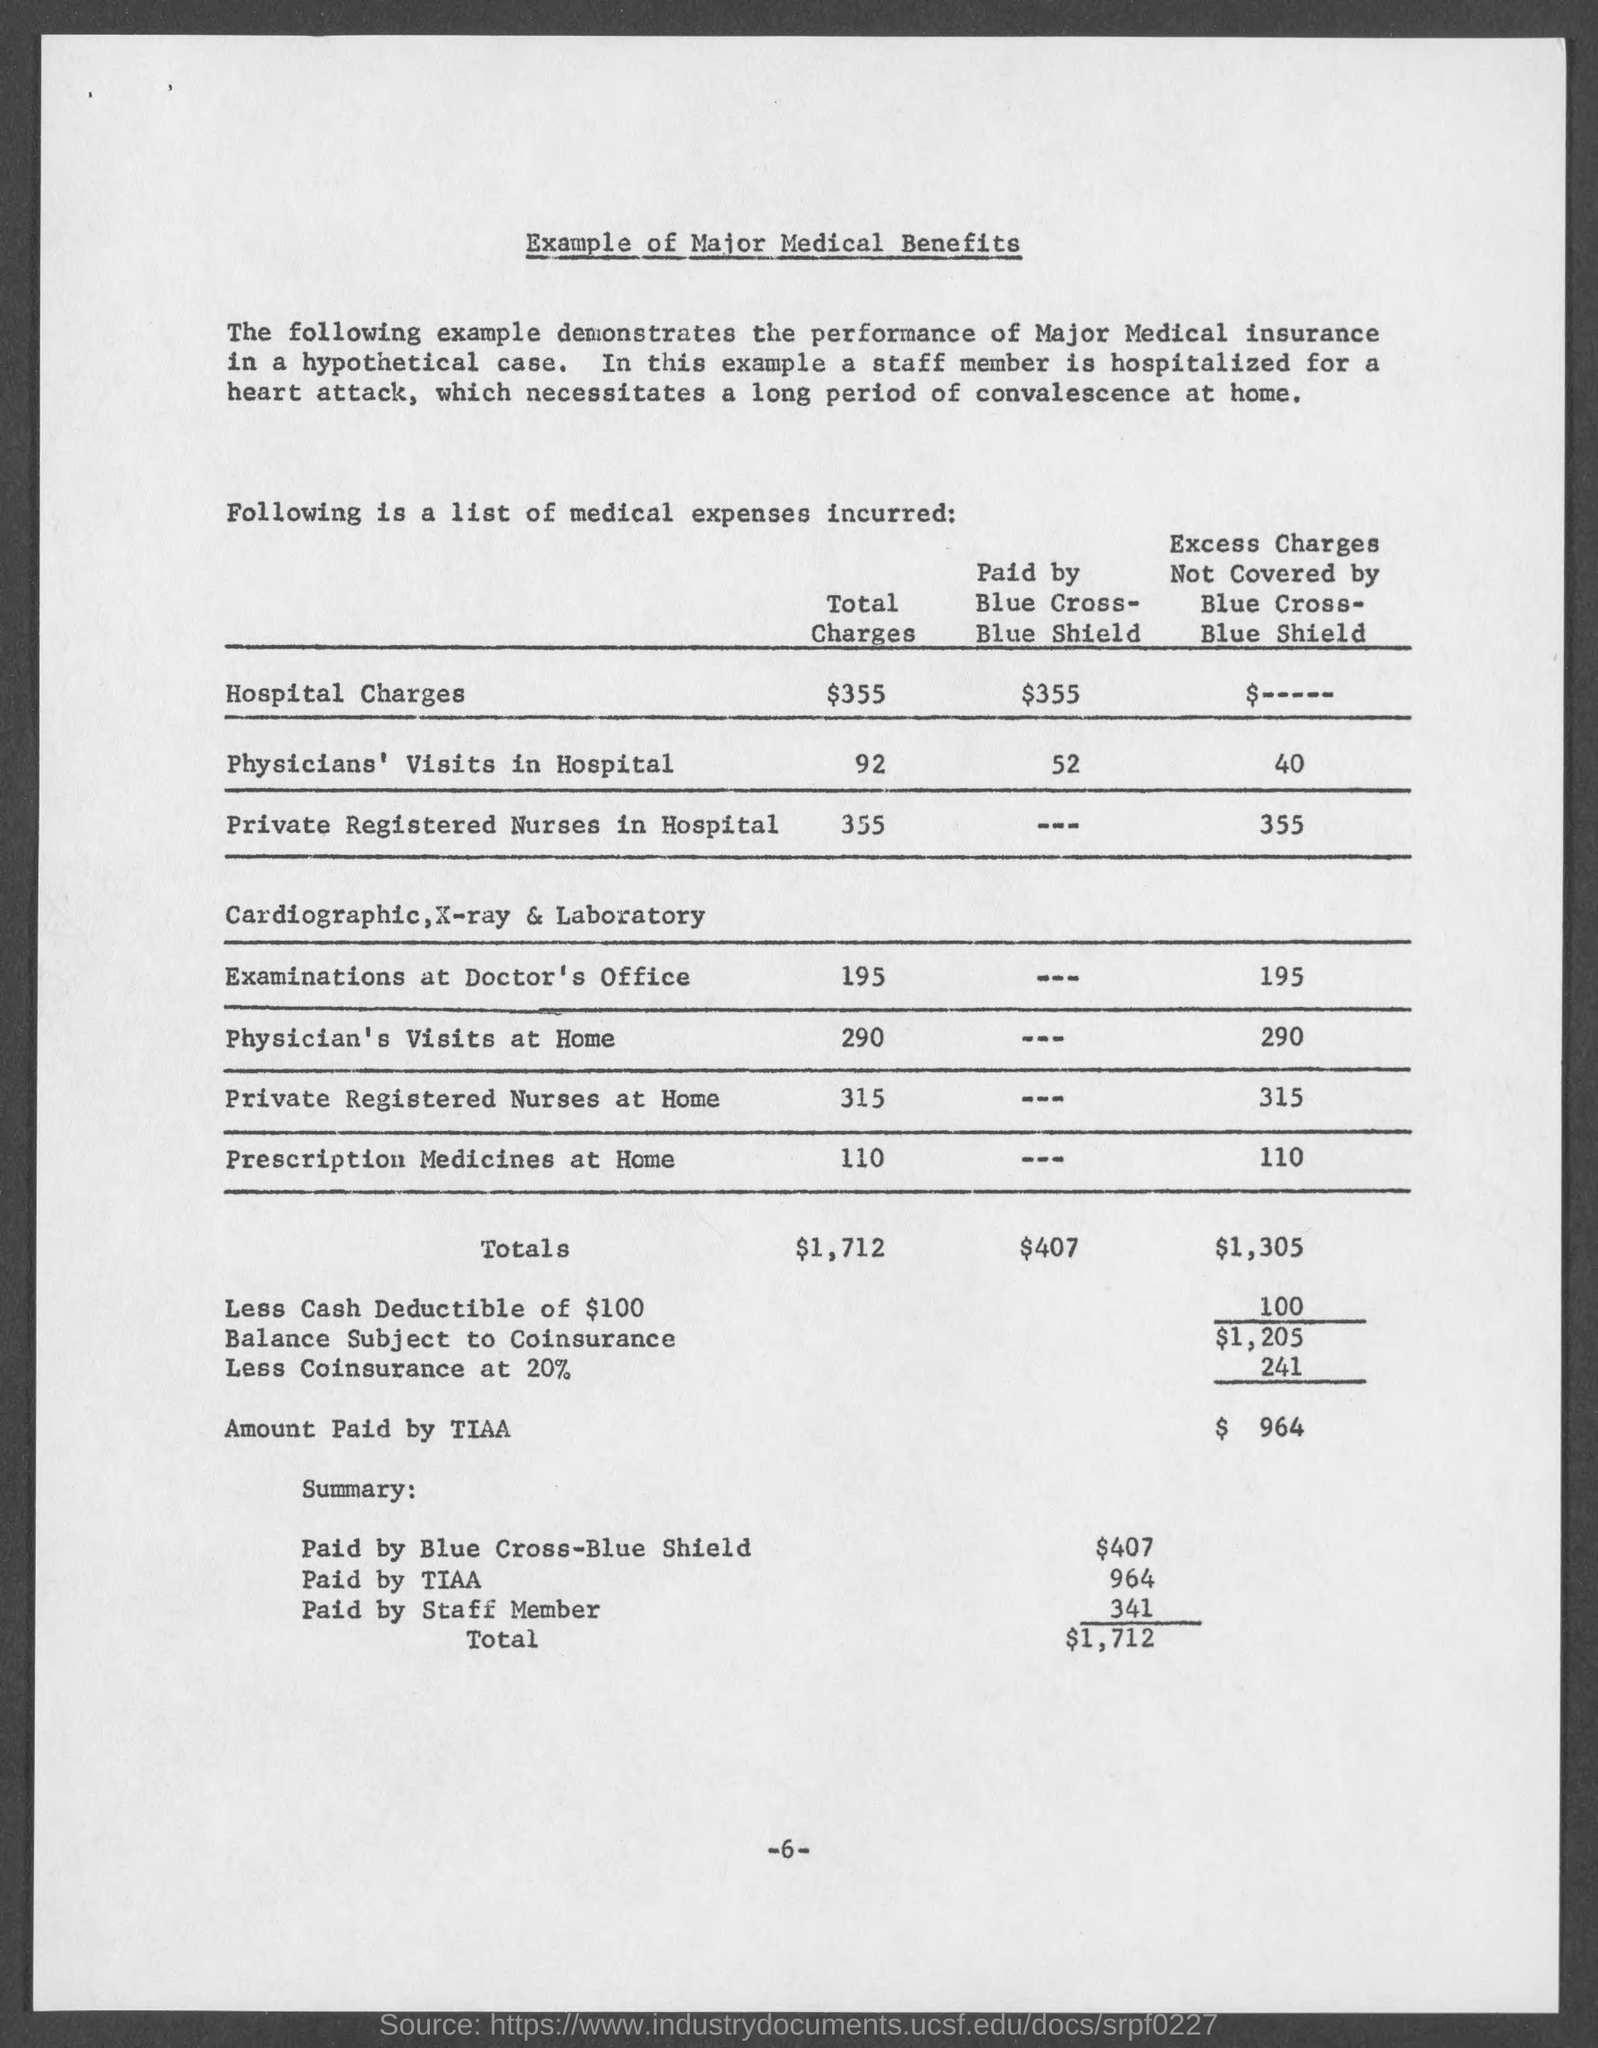What is the Total Charges for Hospital Charges?
Ensure brevity in your answer.  $355. What is the Total Charges for Physicians' Visits in hospital?
Give a very brief answer. 92. What is the Total Charges for private registered nurses in hospital?
Your response must be concise. 355. What is the Total Charges for Examinations at Doctor's office?
Your response must be concise. 195. What is the Total Charges for Physician's visits at home?
Your response must be concise. 290. What is the Total Charges for Private registered nurses at home?
Provide a succinct answer. 315. What is the Total Charges for Prescription Medicinea at home?
Make the answer very short. 110. What is the amount paid by TIAA?
Keep it short and to the point. $964. What is the amount paid by Blue cross-Blue Shield?
Provide a short and direct response. $407. What is the amount paid by staff member?
Offer a very short reply. 341. 